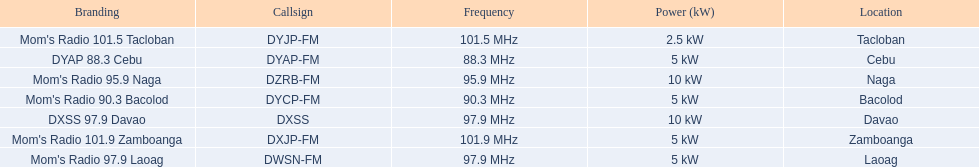What is the only radio station with a frequency below 90 mhz? DYAP 88.3 Cebu. 